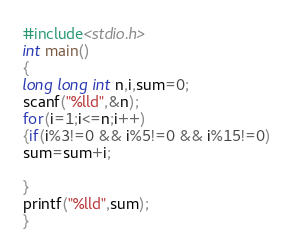Convert code to text. <code><loc_0><loc_0><loc_500><loc_500><_C_>#include<stdio.h>
int main()
{
long long int n,i,sum=0;
scanf("%lld",&n);
for(i=1;i<=n;i++)
{if(i%3!=0 && i%5!=0 && i%15!=0)
sum=sum+i;

}
printf("%lld",sum);
}
</code> 